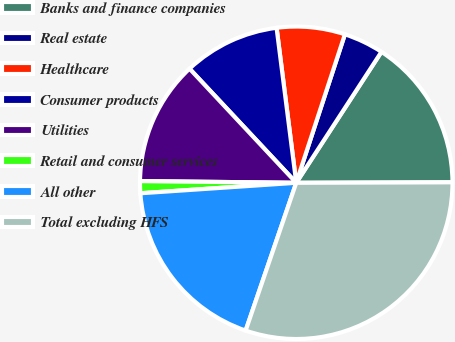Convert chart. <chart><loc_0><loc_0><loc_500><loc_500><pie_chart><fcel>Banks and finance companies<fcel>Real estate<fcel>Healthcare<fcel>Consumer products<fcel>Utilities<fcel>Retail and consumer services<fcel>All other<fcel>Total excluding HFS<nl><fcel>15.77%<fcel>4.14%<fcel>7.05%<fcel>9.96%<fcel>12.86%<fcel>1.24%<fcel>18.68%<fcel>30.3%<nl></chart> 